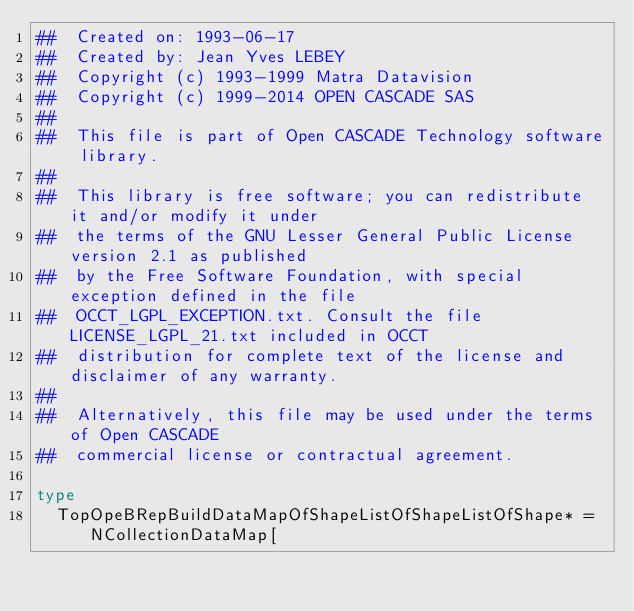<code> <loc_0><loc_0><loc_500><loc_500><_Nim_>##  Created on: 1993-06-17
##  Created by: Jean Yves LEBEY
##  Copyright (c) 1993-1999 Matra Datavision
##  Copyright (c) 1999-2014 OPEN CASCADE SAS
##
##  This file is part of Open CASCADE Technology software library.
##
##  This library is free software; you can redistribute it and/or modify it under
##  the terms of the GNU Lesser General Public License version 2.1 as published
##  by the Free Software Foundation, with special exception defined in the file
##  OCCT_LGPL_EXCEPTION.txt. Consult the file LICENSE_LGPL_21.txt included in OCCT
##  distribution for complete text of the license and disclaimer of any warranty.
##
##  Alternatively, this file may be used under the terms of Open CASCADE
##  commercial license or contractual agreement.

type
  TopOpeBRepBuildDataMapOfShapeListOfShapeListOfShape* = NCollectionDataMap[</code> 